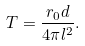<formula> <loc_0><loc_0><loc_500><loc_500>T = \frac { r _ { 0 } d } { 4 \pi l ^ { 2 } } .</formula> 